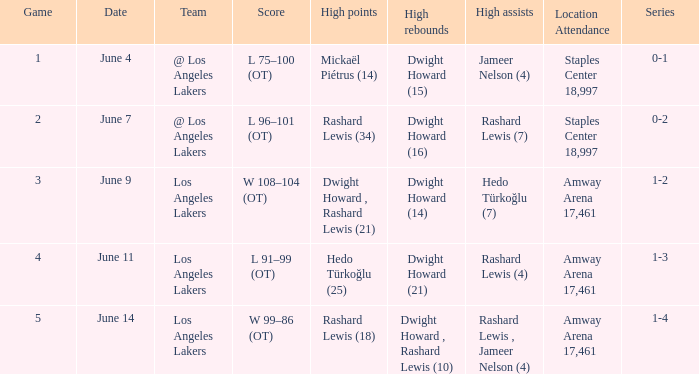What is the highest Game, when High Assists is "Hedo Türkoğlu (7)"? 3.0. 